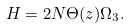<formula> <loc_0><loc_0><loc_500><loc_500>H = 2 N \Theta ( z ) \Omega _ { 3 } .</formula> 